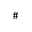Convert formula to latex. <formula><loc_0><loc_0><loc_500><loc_500>\#</formula> 